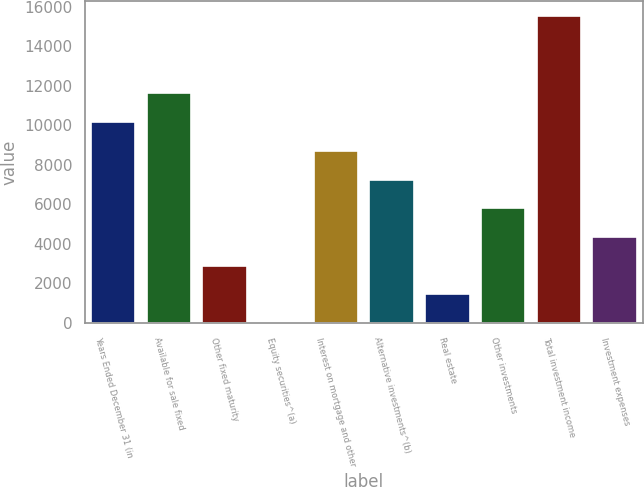Convert chart. <chart><loc_0><loc_0><loc_500><loc_500><bar_chart><fcel>Years Ended December 31 (in<fcel>Available for sale fixed<fcel>Other fixed maturity<fcel>Equity securities^(a)<fcel>Interest on mortgage and other<fcel>Alternative investments^(b)<fcel>Real estate<fcel>Other investments<fcel>Total investment income<fcel>Investment expenses<nl><fcel>10164.1<fcel>11615.4<fcel>2907.6<fcel>5<fcel>8712.8<fcel>7261.5<fcel>1456.3<fcel>5810.2<fcel>15516.3<fcel>4358.9<nl></chart> 